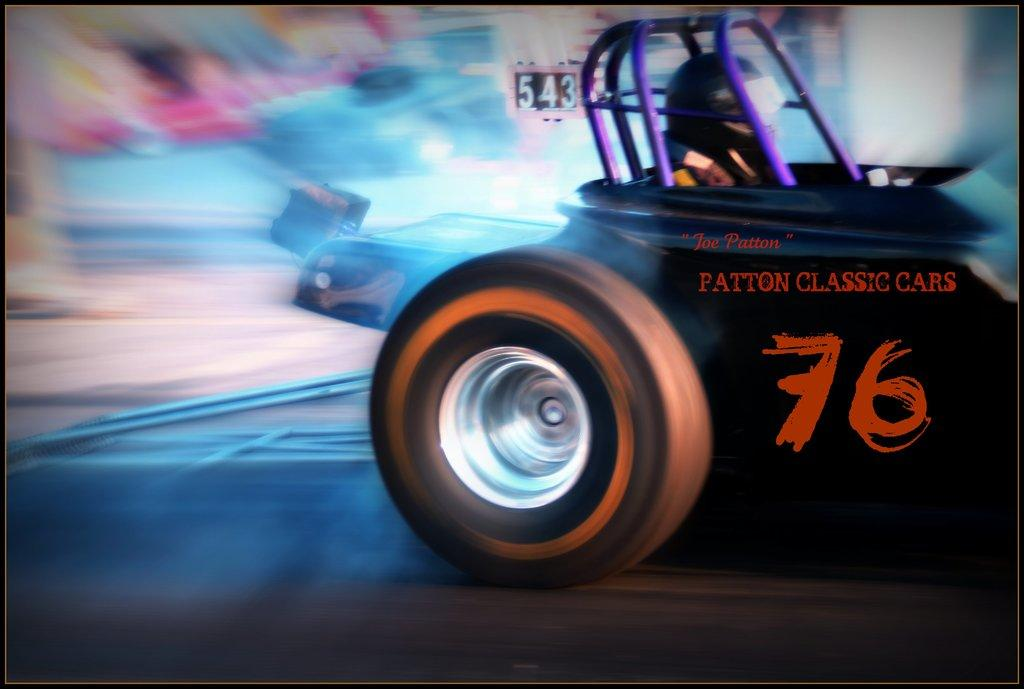What is the main subject of the image? There is a person sitting inside a car in the image. What can be seen in the background of the image? There are other cars racing on the road in the background. How would you describe the appearance of the background? The background appears blurry. What type of tray is being used by the goose in the image? There is no goose or tray present in the image. 